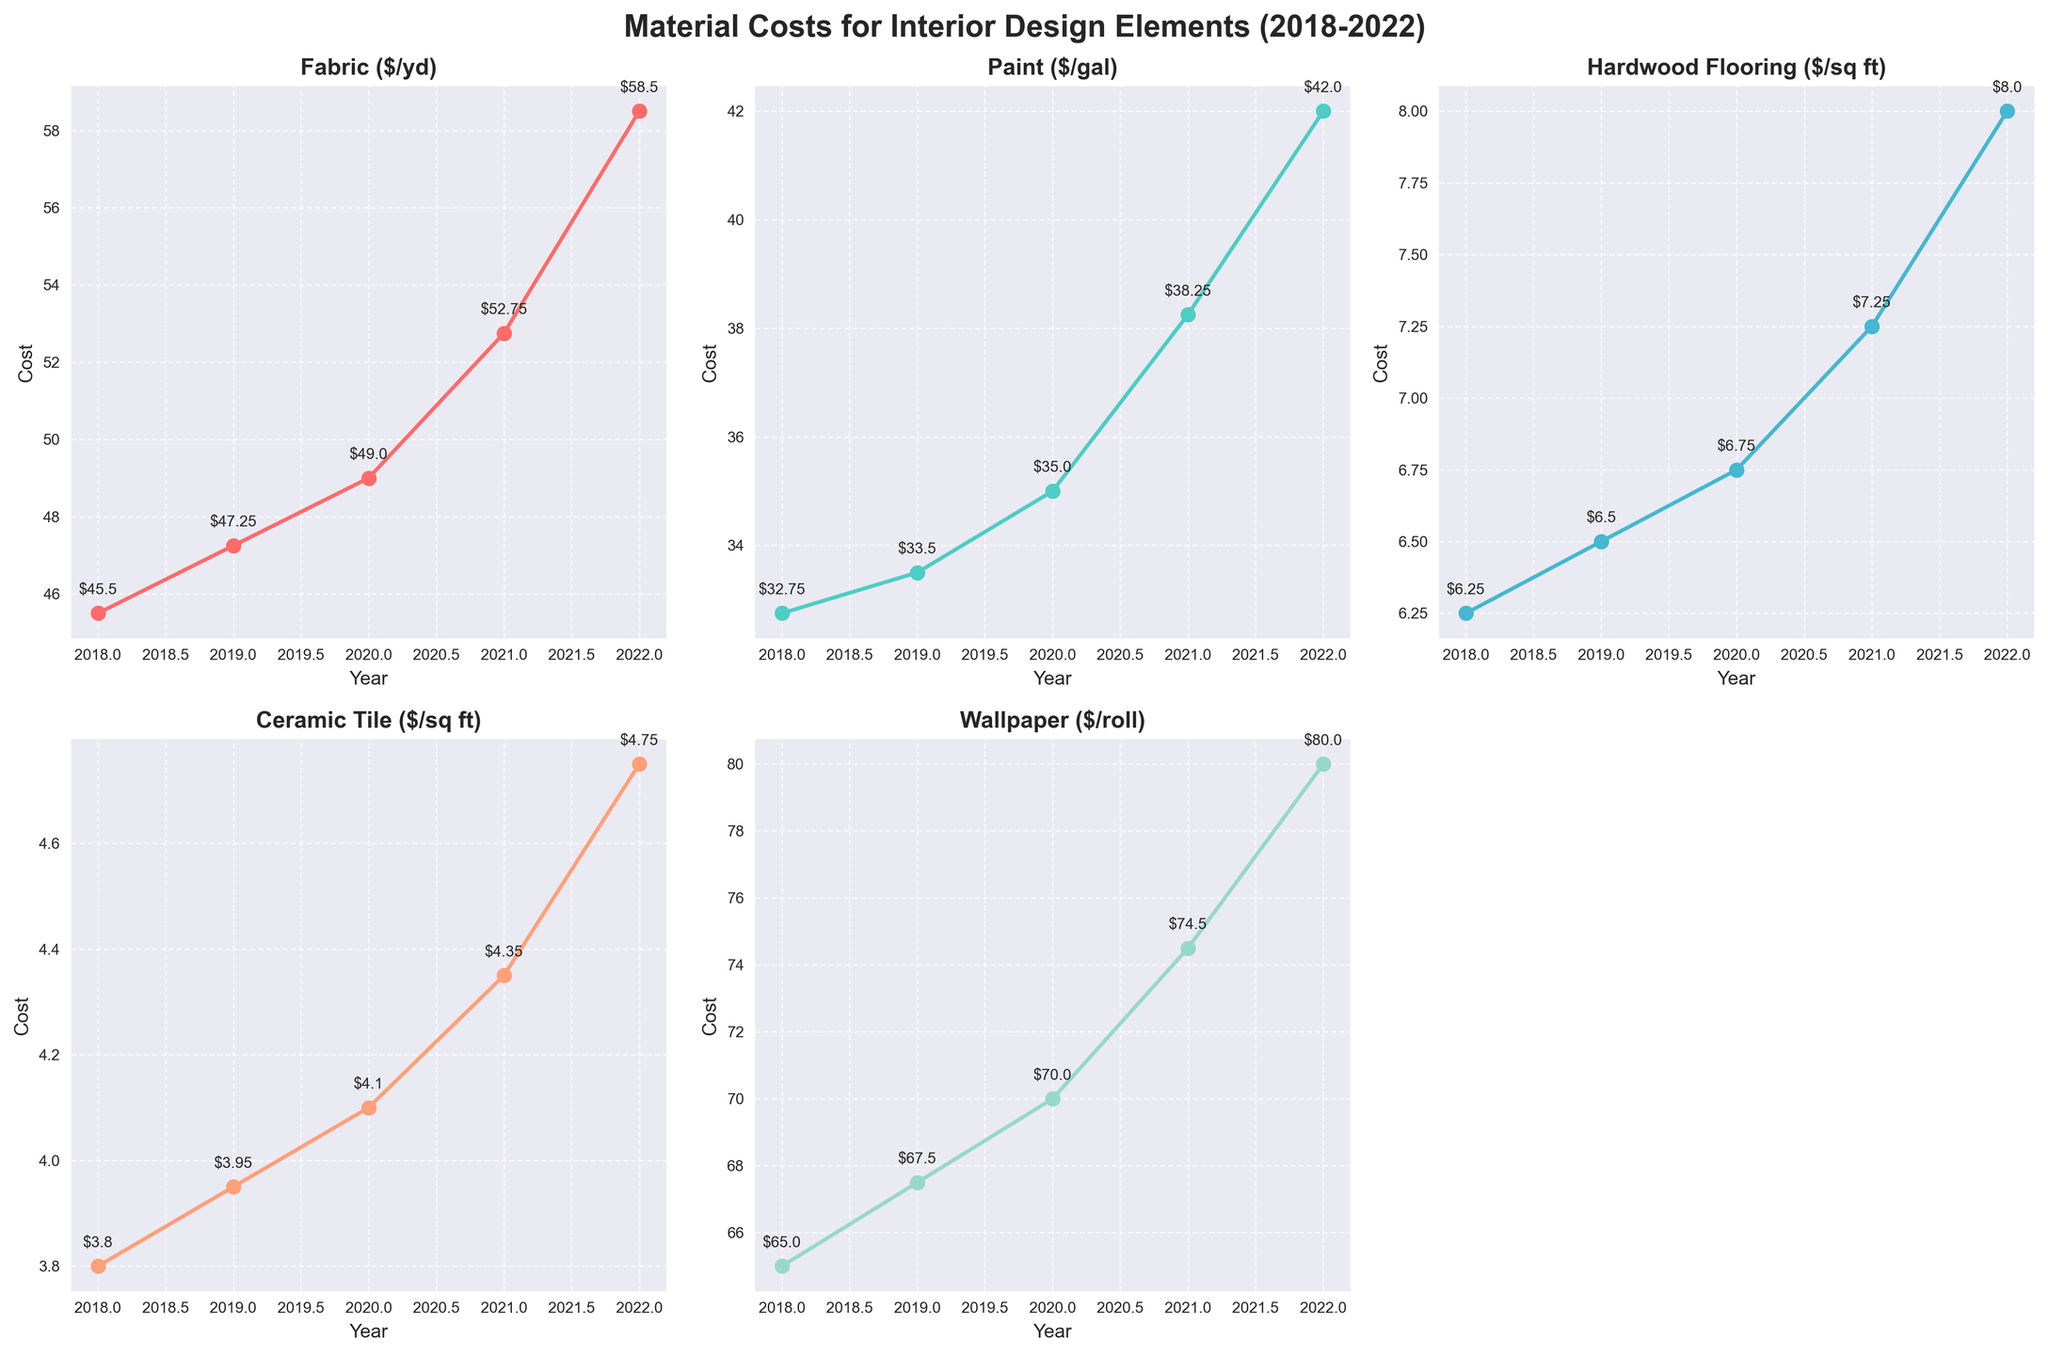What's the title of the figure? The title is at the top of the figure, and it reads "Material Costs for Interior Design Elements (2018-2022)".
Answer: Material Costs for Interior Design Elements (2018-2022) Which material saw the highest cost increase from 2018 to 2022? By observing the plot markers and annotating values, the Fabric cost increased from $45.50 to $58.50, Paint from $32.75 to $42.00, Hardwood Flooring from $6.25 to $8.00, Ceramic Tile from $3.80 to $4.75, and Wallpaper from $65.00 to $80.00. The Wallpaper saw the highest increase.
Answer: Wallpaper What is the cost of Paint per gallon in 2020? The sub-plot for Paint shows the cost in 2020 marked as $35.00.
Answer: $35.00 In which year did Hardwood Flooring cost $7.25 per square foot? The sub-plot for Hardwood Flooring shows year-by-year changes, and $7.25 is annotated for the year 2021.
Answer: 2021 Which material had the most stable cost change over the five years? Comparing the y-axis labels and annotations, Paint's cost increments were most uniform, with a small and steady increase each year.
Answer: Paint What is the difference in cost for Ceramic Tile between 2018 and 2022? The cost of Ceramic Tile in 2022 is $4.75, and in 2018 it was $3.80. The difference is $4.75 - $3.80 = $0.95.
Answer: $0.95 What was the average cost of Fabric per yard from 2018 to 2022? The Fabric costs over the years are $45.50, $47.25, $49.00, $52.75, and $58.50. Summing them gives 252.00, which averaged over 5 years is 252.00 / 5 = 50.40.
Answer: $50.40 Did the cost of Wallpaper ever decrease in any year from 2018 to 2022? Observing the plot for Wallpaper, its cost shows a steady increase with no visible decrease in any year.
Answer: No Which material's cost doubled in value from 2018 to 2022? Observing all subplots and their annotations, none of the materials show a doubled cost over the five-year span. At most, Wallpaper's cost increased from $65.00 to $80.00.
Answer: None Was there any year where the cost of Hardwood Flooring remained the same as the previous year? Inspecting the data points for Hardwood Flooring, every year marks an incremental increase with no years having the same cost consecutively.
Answer: No 